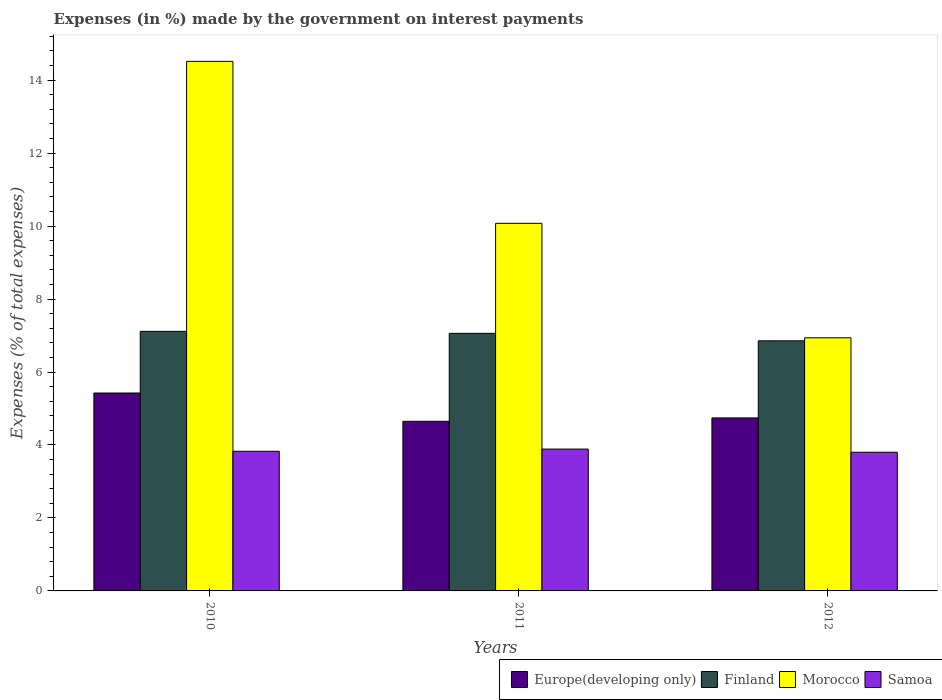How many different coloured bars are there?
Give a very brief answer. 4. Are the number of bars on each tick of the X-axis equal?
Ensure brevity in your answer.  Yes. How many bars are there on the 1st tick from the right?
Your answer should be compact. 4. In how many cases, is the number of bars for a given year not equal to the number of legend labels?
Keep it short and to the point. 0. What is the percentage of expenses made by the government on interest payments in Europe(developing only) in 2012?
Make the answer very short. 4.74. Across all years, what is the maximum percentage of expenses made by the government on interest payments in Finland?
Your answer should be compact. 7.11. Across all years, what is the minimum percentage of expenses made by the government on interest payments in Finland?
Offer a terse response. 6.85. In which year was the percentage of expenses made by the government on interest payments in Morocco minimum?
Give a very brief answer. 2012. What is the total percentage of expenses made by the government on interest payments in Finland in the graph?
Your response must be concise. 21.03. What is the difference between the percentage of expenses made by the government on interest payments in Europe(developing only) in 2010 and that in 2012?
Your answer should be very brief. 0.68. What is the difference between the percentage of expenses made by the government on interest payments in Morocco in 2011 and the percentage of expenses made by the government on interest payments in Finland in 2010?
Your answer should be very brief. 2.96. What is the average percentage of expenses made by the government on interest payments in Finland per year?
Make the answer very short. 7.01. In the year 2012, what is the difference between the percentage of expenses made by the government on interest payments in Morocco and percentage of expenses made by the government on interest payments in Samoa?
Your answer should be compact. 3.14. What is the ratio of the percentage of expenses made by the government on interest payments in Samoa in 2011 to that in 2012?
Your response must be concise. 1.02. Is the difference between the percentage of expenses made by the government on interest payments in Morocco in 2010 and 2011 greater than the difference between the percentage of expenses made by the government on interest payments in Samoa in 2010 and 2011?
Keep it short and to the point. Yes. What is the difference between the highest and the second highest percentage of expenses made by the government on interest payments in Samoa?
Provide a succinct answer. 0.06. What is the difference between the highest and the lowest percentage of expenses made by the government on interest payments in Finland?
Provide a succinct answer. 0.26. Is it the case that in every year, the sum of the percentage of expenses made by the government on interest payments in Europe(developing only) and percentage of expenses made by the government on interest payments in Finland is greater than the sum of percentage of expenses made by the government on interest payments in Samoa and percentage of expenses made by the government on interest payments in Morocco?
Your response must be concise. Yes. What does the 1st bar from the left in 2012 represents?
Offer a very short reply. Europe(developing only). What does the 2nd bar from the right in 2011 represents?
Give a very brief answer. Morocco. Is it the case that in every year, the sum of the percentage of expenses made by the government on interest payments in Europe(developing only) and percentage of expenses made by the government on interest payments in Finland is greater than the percentage of expenses made by the government on interest payments in Morocco?
Offer a terse response. No. How many bars are there?
Give a very brief answer. 12. What is the difference between two consecutive major ticks on the Y-axis?
Provide a short and direct response. 2. Are the values on the major ticks of Y-axis written in scientific E-notation?
Your response must be concise. No. How many legend labels are there?
Provide a succinct answer. 4. How are the legend labels stacked?
Provide a short and direct response. Horizontal. What is the title of the graph?
Your answer should be compact. Expenses (in %) made by the government on interest payments. What is the label or title of the Y-axis?
Ensure brevity in your answer.  Expenses (% of total expenses). What is the Expenses (% of total expenses) in Europe(developing only) in 2010?
Provide a short and direct response. 5.42. What is the Expenses (% of total expenses) in Finland in 2010?
Keep it short and to the point. 7.11. What is the Expenses (% of total expenses) of Morocco in 2010?
Keep it short and to the point. 14.51. What is the Expenses (% of total expenses) in Samoa in 2010?
Give a very brief answer. 3.83. What is the Expenses (% of total expenses) of Europe(developing only) in 2011?
Your answer should be very brief. 4.65. What is the Expenses (% of total expenses) in Finland in 2011?
Offer a terse response. 7.06. What is the Expenses (% of total expenses) in Morocco in 2011?
Your answer should be very brief. 10.07. What is the Expenses (% of total expenses) of Samoa in 2011?
Keep it short and to the point. 3.89. What is the Expenses (% of total expenses) in Europe(developing only) in 2012?
Keep it short and to the point. 4.74. What is the Expenses (% of total expenses) in Finland in 2012?
Your answer should be very brief. 6.85. What is the Expenses (% of total expenses) of Morocco in 2012?
Your answer should be compact. 6.94. What is the Expenses (% of total expenses) of Samoa in 2012?
Your answer should be compact. 3.8. Across all years, what is the maximum Expenses (% of total expenses) of Europe(developing only)?
Make the answer very short. 5.42. Across all years, what is the maximum Expenses (% of total expenses) in Finland?
Make the answer very short. 7.11. Across all years, what is the maximum Expenses (% of total expenses) in Morocco?
Provide a succinct answer. 14.51. Across all years, what is the maximum Expenses (% of total expenses) in Samoa?
Ensure brevity in your answer.  3.89. Across all years, what is the minimum Expenses (% of total expenses) of Europe(developing only)?
Your response must be concise. 4.65. Across all years, what is the minimum Expenses (% of total expenses) in Finland?
Offer a terse response. 6.85. Across all years, what is the minimum Expenses (% of total expenses) in Morocco?
Ensure brevity in your answer.  6.94. Across all years, what is the minimum Expenses (% of total expenses) of Samoa?
Give a very brief answer. 3.8. What is the total Expenses (% of total expenses) in Europe(developing only) in the graph?
Provide a succinct answer. 14.81. What is the total Expenses (% of total expenses) of Finland in the graph?
Offer a very short reply. 21.03. What is the total Expenses (% of total expenses) of Morocco in the graph?
Make the answer very short. 31.53. What is the total Expenses (% of total expenses) of Samoa in the graph?
Ensure brevity in your answer.  11.52. What is the difference between the Expenses (% of total expenses) of Europe(developing only) in 2010 and that in 2011?
Provide a short and direct response. 0.78. What is the difference between the Expenses (% of total expenses) of Finland in 2010 and that in 2011?
Offer a very short reply. 0.05. What is the difference between the Expenses (% of total expenses) of Morocco in 2010 and that in 2011?
Keep it short and to the point. 4.44. What is the difference between the Expenses (% of total expenses) in Samoa in 2010 and that in 2011?
Provide a succinct answer. -0.06. What is the difference between the Expenses (% of total expenses) in Europe(developing only) in 2010 and that in 2012?
Provide a short and direct response. 0.68. What is the difference between the Expenses (% of total expenses) of Finland in 2010 and that in 2012?
Provide a succinct answer. 0.26. What is the difference between the Expenses (% of total expenses) in Morocco in 2010 and that in 2012?
Your response must be concise. 7.58. What is the difference between the Expenses (% of total expenses) of Samoa in 2010 and that in 2012?
Your response must be concise. 0.03. What is the difference between the Expenses (% of total expenses) in Europe(developing only) in 2011 and that in 2012?
Keep it short and to the point. -0.09. What is the difference between the Expenses (% of total expenses) in Finland in 2011 and that in 2012?
Give a very brief answer. 0.21. What is the difference between the Expenses (% of total expenses) in Morocco in 2011 and that in 2012?
Offer a very short reply. 3.14. What is the difference between the Expenses (% of total expenses) in Samoa in 2011 and that in 2012?
Your answer should be compact. 0.09. What is the difference between the Expenses (% of total expenses) of Europe(developing only) in 2010 and the Expenses (% of total expenses) of Finland in 2011?
Keep it short and to the point. -1.64. What is the difference between the Expenses (% of total expenses) in Europe(developing only) in 2010 and the Expenses (% of total expenses) in Morocco in 2011?
Provide a short and direct response. -4.65. What is the difference between the Expenses (% of total expenses) of Europe(developing only) in 2010 and the Expenses (% of total expenses) of Samoa in 2011?
Your answer should be very brief. 1.54. What is the difference between the Expenses (% of total expenses) in Finland in 2010 and the Expenses (% of total expenses) in Morocco in 2011?
Offer a terse response. -2.96. What is the difference between the Expenses (% of total expenses) of Finland in 2010 and the Expenses (% of total expenses) of Samoa in 2011?
Offer a very short reply. 3.23. What is the difference between the Expenses (% of total expenses) in Morocco in 2010 and the Expenses (% of total expenses) in Samoa in 2011?
Make the answer very short. 10.63. What is the difference between the Expenses (% of total expenses) in Europe(developing only) in 2010 and the Expenses (% of total expenses) in Finland in 2012?
Offer a terse response. -1.43. What is the difference between the Expenses (% of total expenses) in Europe(developing only) in 2010 and the Expenses (% of total expenses) in Morocco in 2012?
Make the answer very short. -1.51. What is the difference between the Expenses (% of total expenses) of Europe(developing only) in 2010 and the Expenses (% of total expenses) of Samoa in 2012?
Provide a succinct answer. 1.62. What is the difference between the Expenses (% of total expenses) of Finland in 2010 and the Expenses (% of total expenses) of Morocco in 2012?
Offer a very short reply. 0.18. What is the difference between the Expenses (% of total expenses) of Finland in 2010 and the Expenses (% of total expenses) of Samoa in 2012?
Make the answer very short. 3.31. What is the difference between the Expenses (% of total expenses) of Morocco in 2010 and the Expenses (% of total expenses) of Samoa in 2012?
Offer a terse response. 10.71. What is the difference between the Expenses (% of total expenses) in Europe(developing only) in 2011 and the Expenses (% of total expenses) in Finland in 2012?
Give a very brief answer. -2.21. What is the difference between the Expenses (% of total expenses) of Europe(developing only) in 2011 and the Expenses (% of total expenses) of Morocco in 2012?
Your response must be concise. -2.29. What is the difference between the Expenses (% of total expenses) of Europe(developing only) in 2011 and the Expenses (% of total expenses) of Samoa in 2012?
Offer a terse response. 0.85. What is the difference between the Expenses (% of total expenses) in Finland in 2011 and the Expenses (% of total expenses) in Morocco in 2012?
Give a very brief answer. 0.12. What is the difference between the Expenses (% of total expenses) of Finland in 2011 and the Expenses (% of total expenses) of Samoa in 2012?
Your answer should be very brief. 3.26. What is the difference between the Expenses (% of total expenses) in Morocco in 2011 and the Expenses (% of total expenses) in Samoa in 2012?
Your response must be concise. 6.27. What is the average Expenses (% of total expenses) in Europe(developing only) per year?
Your answer should be compact. 4.94. What is the average Expenses (% of total expenses) of Finland per year?
Provide a short and direct response. 7.01. What is the average Expenses (% of total expenses) in Morocco per year?
Make the answer very short. 10.51. What is the average Expenses (% of total expenses) of Samoa per year?
Keep it short and to the point. 3.84. In the year 2010, what is the difference between the Expenses (% of total expenses) in Europe(developing only) and Expenses (% of total expenses) in Finland?
Make the answer very short. -1.69. In the year 2010, what is the difference between the Expenses (% of total expenses) of Europe(developing only) and Expenses (% of total expenses) of Morocco?
Your answer should be very brief. -9.09. In the year 2010, what is the difference between the Expenses (% of total expenses) of Europe(developing only) and Expenses (% of total expenses) of Samoa?
Your response must be concise. 1.6. In the year 2010, what is the difference between the Expenses (% of total expenses) of Finland and Expenses (% of total expenses) of Morocco?
Offer a very short reply. -7.4. In the year 2010, what is the difference between the Expenses (% of total expenses) in Finland and Expenses (% of total expenses) in Samoa?
Your answer should be very brief. 3.29. In the year 2010, what is the difference between the Expenses (% of total expenses) of Morocco and Expenses (% of total expenses) of Samoa?
Provide a short and direct response. 10.69. In the year 2011, what is the difference between the Expenses (% of total expenses) of Europe(developing only) and Expenses (% of total expenses) of Finland?
Offer a very short reply. -2.41. In the year 2011, what is the difference between the Expenses (% of total expenses) in Europe(developing only) and Expenses (% of total expenses) in Morocco?
Your response must be concise. -5.43. In the year 2011, what is the difference between the Expenses (% of total expenses) of Europe(developing only) and Expenses (% of total expenses) of Samoa?
Make the answer very short. 0.76. In the year 2011, what is the difference between the Expenses (% of total expenses) in Finland and Expenses (% of total expenses) in Morocco?
Keep it short and to the point. -3.01. In the year 2011, what is the difference between the Expenses (% of total expenses) of Finland and Expenses (% of total expenses) of Samoa?
Provide a short and direct response. 3.17. In the year 2011, what is the difference between the Expenses (% of total expenses) in Morocco and Expenses (% of total expenses) in Samoa?
Offer a terse response. 6.19. In the year 2012, what is the difference between the Expenses (% of total expenses) of Europe(developing only) and Expenses (% of total expenses) of Finland?
Ensure brevity in your answer.  -2.11. In the year 2012, what is the difference between the Expenses (% of total expenses) of Europe(developing only) and Expenses (% of total expenses) of Morocco?
Provide a succinct answer. -2.2. In the year 2012, what is the difference between the Expenses (% of total expenses) in Europe(developing only) and Expenses (% of total expenses) in Samoa?
Your response must be concise. 0.94. In the year 2012, what is the difference between the Expenses (% of total expenses) in Finland and Expenses (% of total expenses) in Morocco?
Provide a succinct answer. -0.08. In the year 2012, what is the difference between the Expenses (% of total expenses) in Finland and Expenses (% of total expenses) in Samoa?
Provide a succinct answer. 3.05. In the year 2012, what is the difference between the Expenses (% of total expenses) in Morocco and Expenses (% of total expenses) in Samoa?
Provide a short and direct response. 3.14. What is the ratio of the Expenses (% of total expenses) of Europe(developing only) in 2010 to that in 2011?
Make the answer very short. 1.17. What is the ratio of the Expenses (% of total expenses) of Finland in 2010 to that in 2011?
Give a very brief answer. 1.01. What is the ratio of the Expenses (% of total expenses) in Morocco in 2010 to that in 2011?
Offer a terse response. 1.44. What is the ratio of the Expenses (% of total expenses) of Samoa in 2010 to that in 2011?
Your response must be concise. 0.98. What is the ratio of the Expenses (% of total expenses) in Europe(developing only) in 2010 to that in 2012?
Provide a short and direct response. 1.14. What is the ratio of the Expenses (% of total expenses) in Finland in 2010 to that in 2012?
Give a very brief answer. 1.04. What is the ratio of the Expenses (% of total expenses) of Morocco in 2010 to that in 2012?
Make the answer very short. 2.09. What is the ratio of the Expenses (% of total expenses) of Samoa in 2010 to that in 2012?
Your answer should be very brief. 1.01. What is the ratio of the Expenses (% of total expenses) of Europe(developing only) in 2011 to that in 2012?
Ensure brevity in your answer.  0.98. What is the ratio of the Expenses (% of total expenses) of Finland in 2011 to that in 2012?
Provide a succinct answer. 1.03. What is the ratio of the Expenses (% of total expenses) of Morocco in 2011 to that in 2012?
Offer a terse response. 1.45. What is the ratio of the Expenses (% of total expenses) in Samoa in 2011 to that in 2012?
Offer a terse response. 1.02. What is the difference between the highest and the second highest Expenses (% of total expenses) of Europe(developing only)?
Offer a very short reply. 0.68. What is the difference between the highest and the second highest Expenses (% of total expenses) in Finland?
Your answer should be compact. 0.05. What is the difference between the highest and the second highest Expenses (% of total expenses) in Morocco?
Provide a short and direct response. 4.44. What is the difference between the highest and the second highest Expenses (% of total expenses) in Samoa?
Give a very brief answer. 0.06. What is the difference between the highest and the lowest Expenses (% of total expenses) of Europe(developing only)?
Give a very brief answer. 0.78. What is the difference between the highest and the lowest Expenses (% of total expenses) of Finland?
Keep it short and to the point. 0.26. What is the difference between the highest and the lowest Expenses (% of total expenses) in Morocco?
Your response must be concise. 7.58. What is the difference between the highest and the lowest Expenses (% of total expenses) of Samoa?
Your answer should be compact. 0.09. 